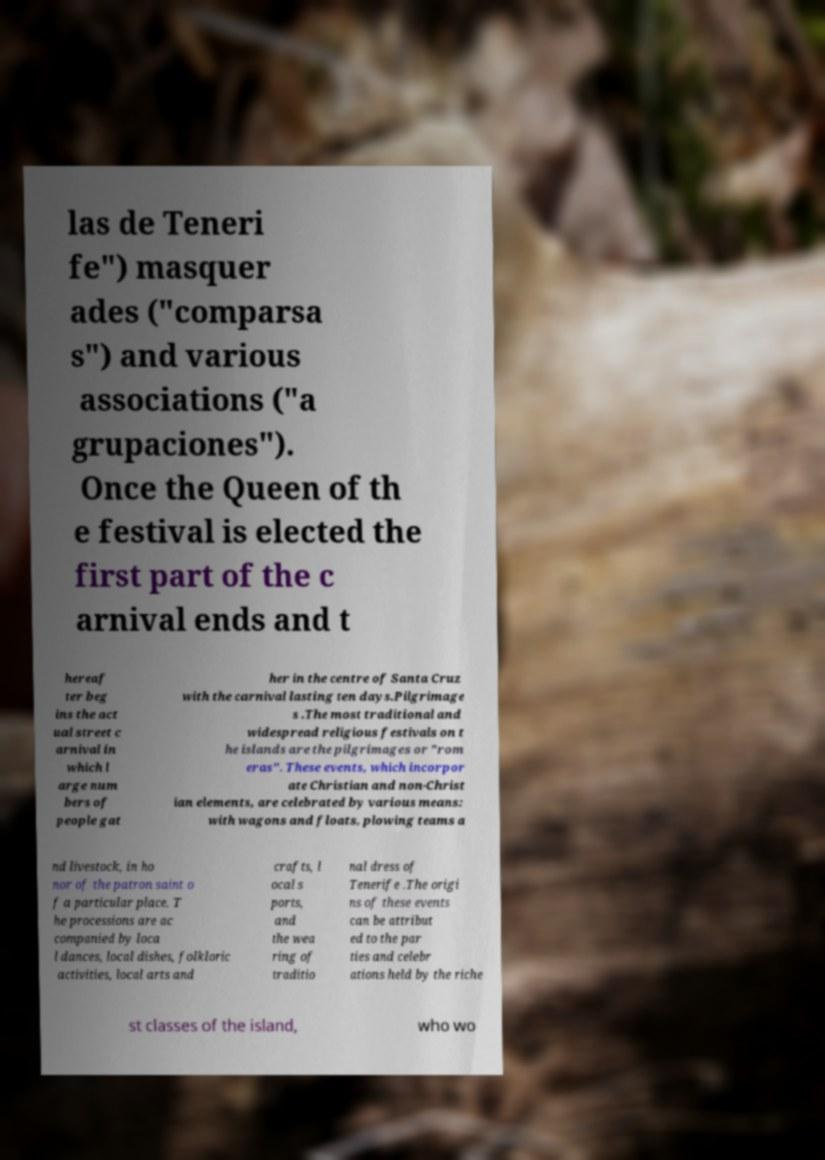For documentation purposes, I need the text within this image transcribed. Could you provide that? las de Teneri fe") masquer ades ("comparsa s") and various associations ("a grupaciones"). Once the Queen of th e festival is elected the first part of the c arnival ends and t hereaf ter beg ins the act ual street c arnival in which l arge num bers of people gat her in the centre of Santa Cruz with the carnival lasting ten days.Pilgrimage s .The most traditional and widespread religious festivals on t he islands are the pilgrimages or "rom eras". These events, which incorpor ate Christian and non-Christ ian elements, are celebrated by various means: with wagons and floats, plowing teams a nd livestock, in ho nor of the patron saint o f a particular place. T he processions are ac companied by loca l dances, local dishes, folkloric activities, local arts and crafts, l ocal s ports, and the wea ring of traditio nal dress of Tenerife .The origi ns of these events can be attribut ed to the par ties and celebr ations held by the riche st classes of the island, who wo 